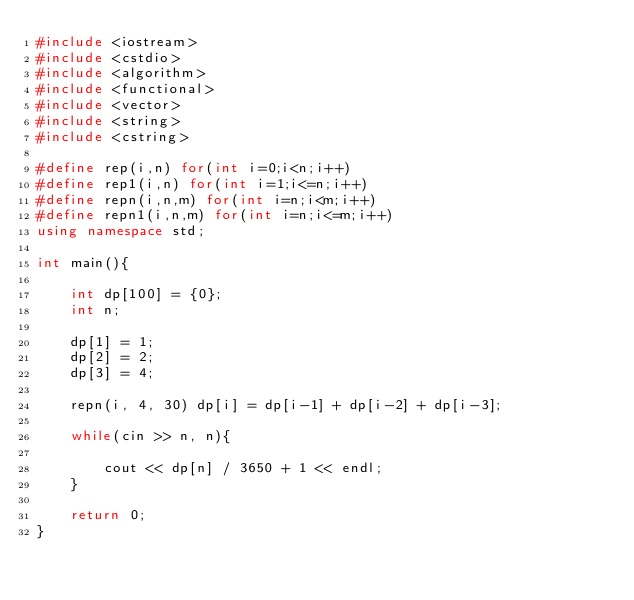Convert code to text. <code><loc_0><loc_0><loc_500><loc_500><_C++_>#include <iostream>
#include <cstdio>
#include <algorithm>
#include <functional>
#include <vector>
#include <string>
#include <cstring>

#define rep(i,n) for(int i=0;i<n;i++)
#define rep1(i,n) for(int i=1;i<=n;i++)
#define repn(i,n,m) for(int i=n;i<m;i++)
#define repn1(i,n,m) for(int i=n;i<=m;i++)
using namespace std;

int main(){

	int dp[100] = {0};
	int n;
	
	dp[1] = 1;
	dp[2] = 2;
	dp[3] = 4;

	repn(i, 4, 30) dp[i] = dp[i-1] + dp[i-2] + dp[i-3];

	while(cin >> n, n){

		cout << dp[n] / 3650 + 1 << endl;
	}

	return 0;
}</code> 